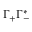<formula> <loc_0><loc_0><loc_500><loc_500>\Gamma _ { + } \Gamma _ { - } ^ { * }</formula> 